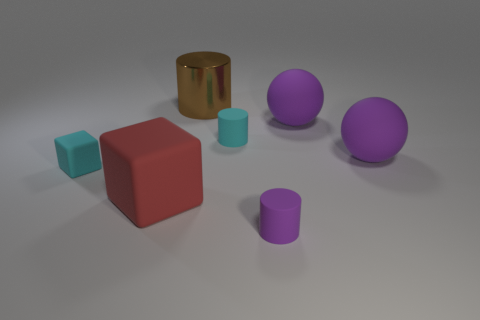Subtract all tiny cylinders. How many cylinders are left? 1 Add 2 metal objects. How many objects exist? 9 Subtract all red blocks. How many blocks are left? 1 Subtract 1 cubes. How many cubes are left? 1 Subtract all blocks. How many objects are left? 5 Subtract all blue balls. Subtract all yellow cylinders. How many balls are left? 2 Subtract all gray spheres. How many yellow cubes are left? 0 Subtract all cyan matte objects. Subtract all small blocks. How many objects are left? 4 Add 7 cyan rubber blocks. How many cyan rubber blocks are left? 8 Add 6 purple rubber balls. How many purple rubber balls exist? 8 